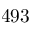Convert formula to latex. <formula><loc_0><loc_0><loc_500><loc_500>4 9 3</formula> 